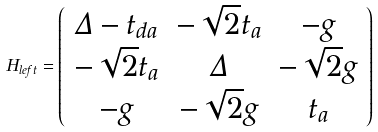<formula> <loc_0><loc_0><loc_500><loc_500>H _ { l e f t } = \left ( \begin{array} { c c c } \Delta - t _ { d a } & - \sqrt { 2 } t _ { a } & - g \\ - \sqrt { 2 } t _ { a } & \Delta & - \sqrt { 2 } g \\ - g & - \sqrt { 2 } g & t _ { a } \end{array} \right )</formula> 